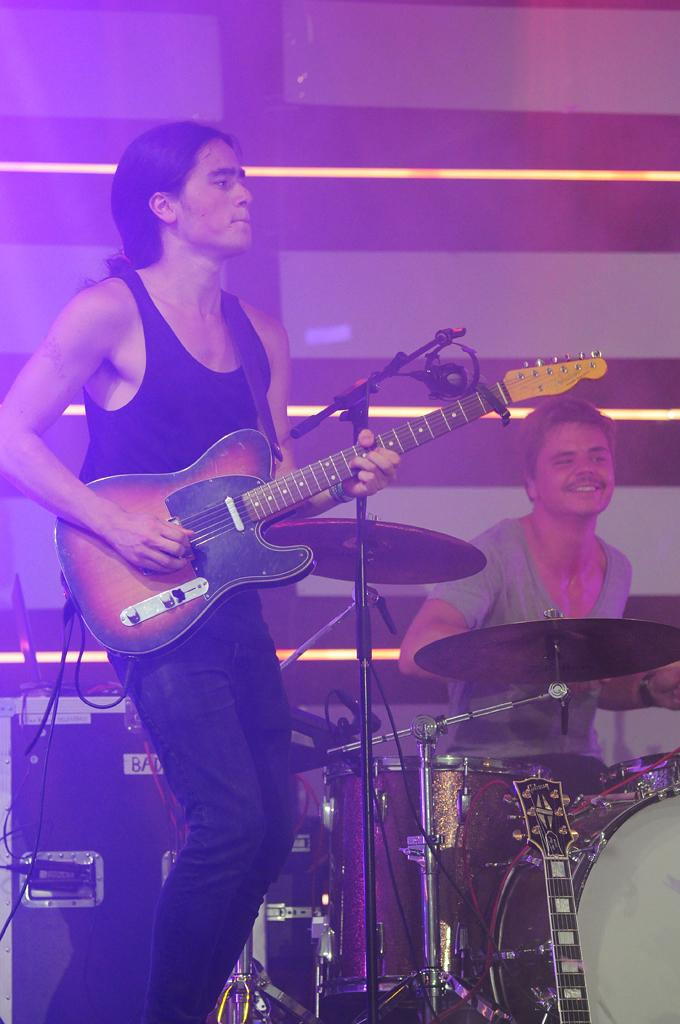How many people are in the image? There are two men in the image. What are the men doing in the image? The men are playing musical instruments. What can be seen in the background of the image? There is a wall in the background of the image. How many chairs are visible in the image? There are no chairs present in the image. 